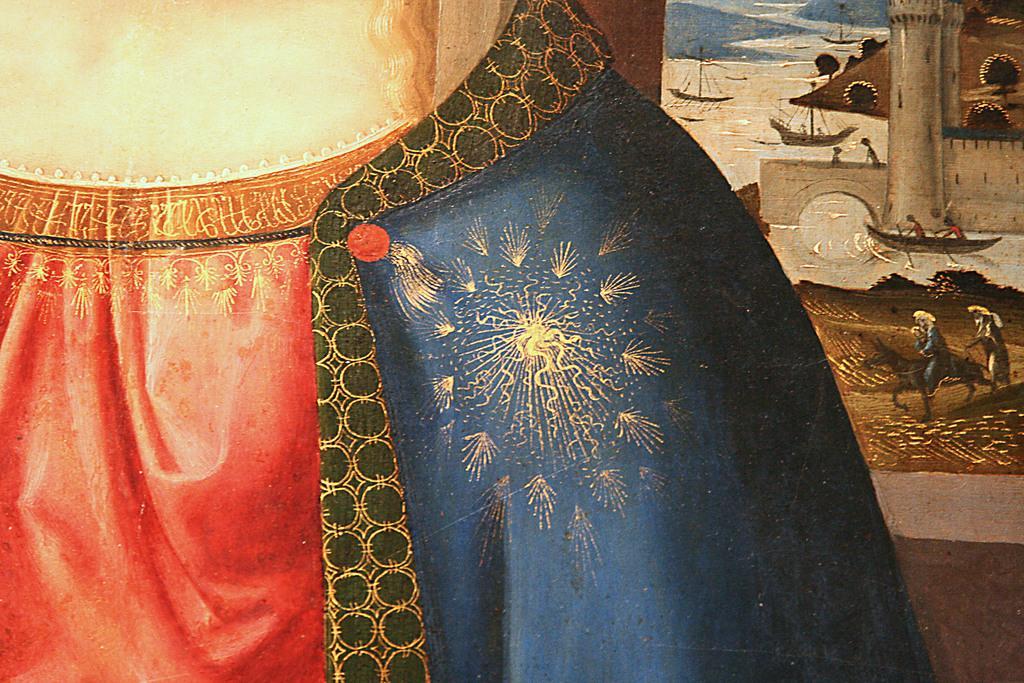Describe this image in one or two sentences. As we can see in the image there is drawing of few people, horses, water, buildings and boats. 